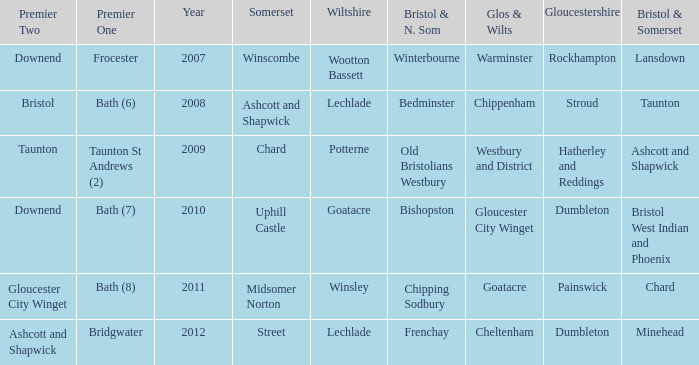What is the year where glos & wilts is gloucester city winget? 2010.0. 